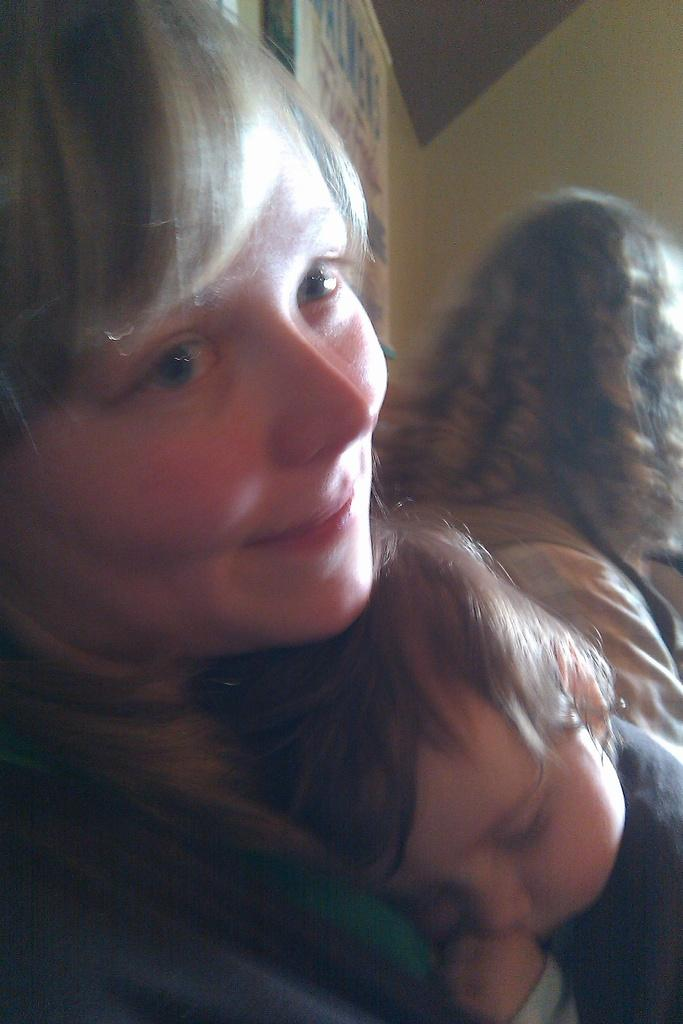What is happening in the foreground of the image? There is a person holding a baby in the foreground of the image. Who else is present in the image? There is another woman sitting beside the person holding the baby. What can be seen in the background of the image? There are boards on the wall in the background of the image. What type of clam is being used as a swing in the image? There is no clam or swing present in the image. 